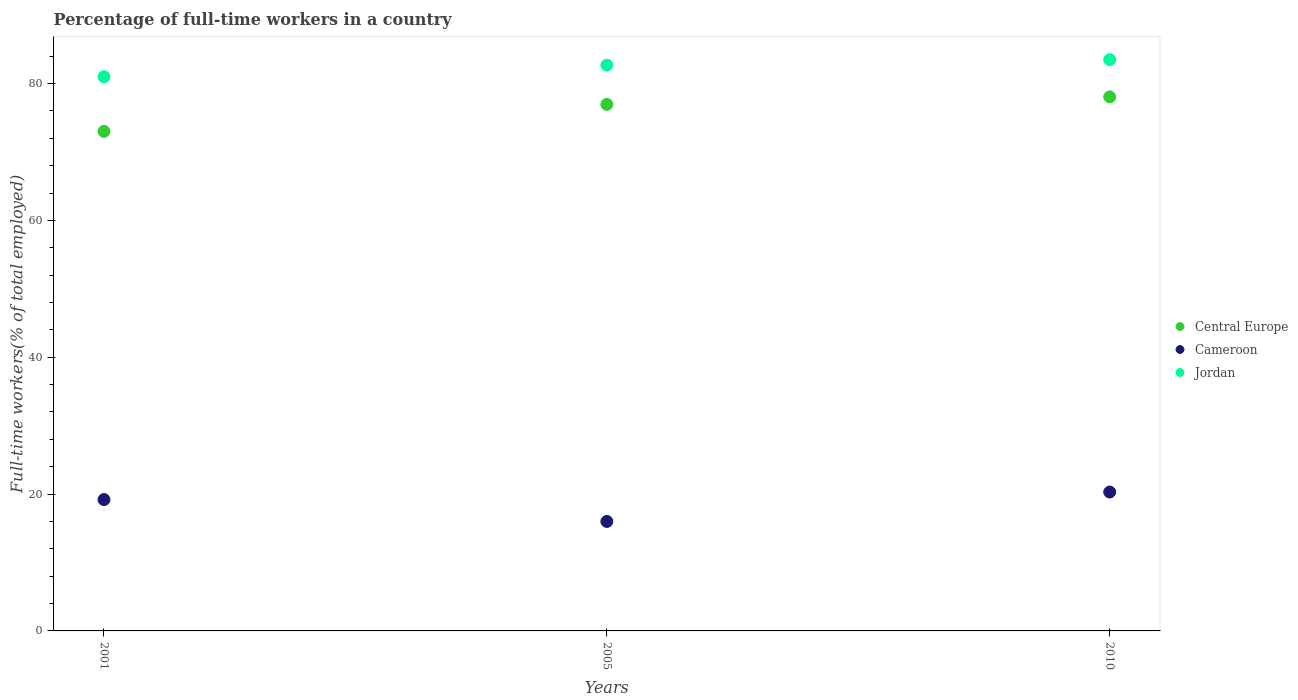Is the number of dotlines equal to the number of legend labels?
Offer a terse response. Yes. What is the percentage of full-time workers in Jordan in 2010?
Ensure brevity in your answer.  83.5. Across all years, what is the maximum percentage of full-time workers in Cameroon?
Give a very brief answer. 20.3. In which year was the percentage of full-time workers in Jordan maximum?
Your answer should be very brief. 2010. What is the total percentage of full-time workers in Jordan in the graph?
Offer a very short reply. 247.2. What is the difference between the percentage of full-time workers in Central Europe in 2001 and that in 2010?
Offer a very short reply. -5.04. What is the difference between the percentage of full-time workers in Central Europe in 2001 and the percentage of full-time workers in Cameroon in 2005?
Provide a short and direct response. 57.02. What is the average percentage of full-time workers in Cameroon per year?
Make the answer very short. 18.5. In the year 2010, what is the difference between the percentage of full-time workers in Central Europe and percentage of full-time workers in Cameroon?
Your answer should be very brief. 57.76. What is the ratio of the percentage of full-time workers in Central Europe in 2001 to that in 2005?
Ensure brevity in your answer.  0.95. Is the percentage of full-time workers in Jordan in 2005 less than that in 2010?
Your response must be concise. Yes. What is the difference between the highest and the second highest percentage of full-time workers in Central Europe?
Ensure brevity in your answer.  1.1. What is the difference between the highest and the lowest percentage of full-time workers in Central Europe?
Provide a short and direct response. 5.04. In how many years, is the percentage of full-time workers in Jordan greater than the average percentage of full-time workers in Jordan taken over all years?
Your response must be concise. 2. Is the percentage of full-time workers in Central Europe strictly greater than the percentage of full-time workers in Cameroon over the years?
Provide a succinct answer. Yes. Is the percentage of full-time workers in Jordan strictly less than the percentage of full-time workers in Central Europe over the years?
Keep it short and to the point. No. How many years are there in the graph?
Ensure brevity in your answer.  3. What is the difference between two consecutive major ticks on the Y-axis?
Ensure brevity in your answer.  20. Does the graph contain grids?
Offer a terse response. No. Where does the legend appear in the graph?
Your answer should be compact. Center right. How many legend labels are there?
Your answer should be compact. 3. How are the legend labels stacked?
Make the answer very short. Vertical. What is the title of the graph?
Make the answer very short. Percentage of full-time workers in a country. What is the label or title of the X-axis?
Provide a short and direct response. Years. What is the label or title of the Y-axis?
Give a very brief answer. Full-time workers(% of total employed). What is the Full-time workers(% of total employed) in Central Europe in 2001?
Give a very brief answer. 73.02. What is the Full-time workers(% of total employed) in Cameroon in 2001?
Your answer should be compact. 19.2. What is the Full-time workers(% of total employed) of Central Europe in 2005?
Give a very brief answer. 76.96. What is the Full-time workers(% of total employed) of Jordan in 2005?
Make the answer very short. 82.7. What is the Full-time workers(% of total employed) in Central Europe in 2010?
Your answer should be compact. 78.06. What is the Full-time workers(% of total employed) of Cameroon in 2010?
Give a very brief answer. 20.3. What is the Full-time workers(% of total employed) of Jordan in 2010?
Give a very brief answer. 83.5. Across all years, what is the maximum Full-time workers(% of total employed) of Central Europe?
Your answer should be compact. 78.06. Across all years, what is the maximum Full-time workers(% of total employed) of Cameroon?
Provide a succinct answer. 20.3. Across all years, what is the maximum Full-time workers(% of total employed) in Jordan?
Ensure brevity in your answer.  83.5. Across all years, what is the minimum Full-time workers(% of total employed) of Central Europe?
Your answer should be very brief. 73.02. What is the total Full-time workers(% of total employed) of Central Europe in the graph?
Offer a terse response. 228.04. What is the total Full-time workers(% of total employed) in Cameroon in the graph?
Provide a succinct answer. 55.5. What is the total Full-time workers(% of total employed) in Jordan in the graph?
Your response must be concise. 247.2. What is the difference between the Full-time workers(% of total employed) of Central Europe in 2001 and that in 2005?
Provide a succinct answer. -3.94. What is the difference between the Full-time workers(% of total employed) in Cameroon in 2001 and that in 2005?
Ensure brevity in your answer.  3.2. What is the difference between the Full-time workers(% of total employed) of Central Europe in 2001 and that in 2010?
Make the answer very short. -5.04. What is the difference between the Full-time workers(% of total employed) of Cameroon in 2001 and that in 2010?
Give a very brief answer. -1.1. What is the difference between the Full-time workers(% of total employed) in Central Europe in 2005 and that in 2010?
Provide a short and direct response. -1.1. What is the difference between the Full-time workers(% of total employed) of Jordan in 2005 and that in 2010?
Make the answer very short. -0.8. What is the difference between the Full-time workers(% of total employed) of Central Europe in 2001 and the Full-time workers(% of total employed) of Cameroon in 2005?
Your answer should be very brief. 57.02. What is the difference between the Full-time workers(% of total employed) of Central Europe in 2001 and the Full-time workers(% of total employed) of Jordan in 2005?
Provide a short and direct response. -9.68. What is the difference between the Full-time workers(% of total employed) in Cameroon in 2001 and the Full-time workers(% of total employed) in Jordan in 2005?
Give a very brief answer. -63.5. What is the difference between the Full-time workers(% of total employed) of Central Europe in 2001 and the Full-time workers(% of total employed) of Cameroon in 2010?
Offer a very short reply. 52.72. What is the difference between the Full-time workers(% of total employed) in Central Europe in 2001 and the Full-time workers(% of total employed) in Jordan in 2010?
Make the answer very short. -10.48. What is the difference between the Full-time workers(% of total employed) of Cameroon in 2001 and the Full-time workers(% of total employed) of Jordan in 2010?
Offer a terse response. -64.3. What is the difference between the Full-time workers(% of total employed) in Central Europe in 2005 and the Full-time workers(% of total employed) in Cameroon in 2010?
Your response must be concise. 56.66. What is the difference between the Full-time workers(% of total employed) of Central Europe in 2005 and the Full-time workers(% of total employed) of Jordan in 2010?
Keep it short and to the point. -6.54. What is the difference between the Full-time workers(% of total employed) of Cameroon in 2005 and the Full-time workers(% of total employed) of Jordan in 2010?
Provide a short and direct response. -67.5. What is the average Full-time workers(% of total employed) in Central Europe per year?
Offer a very short reply. 76.01. What is the average Full-time workers(% of total employed) in Cameroon per year?
Offer a very short reply. 18.5. What is the average Full-time workers(% of total employed) of Jordan per year?
Offer a terse response. 82.4. In the year 2001, what is the difference between the Full-time workers(% of total employed) in Central Europe and Full-time workers(% of total employed) in Cameroon?
Make the answer very short. 53.82. In the year 2001, what is the difference between the Full-time workers(% of total employed) in Central Europe and Full-time workers(% of total employed) in Jordan?
Offer a very short reply. -7.98. In the year 2001, what is the difference between the Full-time workers(% of total employed) of Cameroon and Full-time workers(% of total employed) of Jordan?
Keep it short and to the point. -61.8. In the year 2005, what is the difference between the Full-time workers(% of total employed) of Central Europe and Full-time workers(% of total employed) of Cameroon?
Offer a very short reply. 60.96. In the year 2005, what is the difference between the Full-time workers(% of total employed) in Central Europe and Full-time workers(% of total employed) in Jordan?
Your answer should be compact. -5.74. In the year 2005, what is the difference between the Full-time workers(% of total employed) in Cameroon and Full-time workers(% of total employed) in Jordan?
Offer a terse response. -66.7. In the year 2010, what is the difference between the Full-time workers(% of total employed) of Central Europe and Full-time workers(% of total employed) of Cameroon?
Make the answer very short. 57.76. In the year 2010, what is the difference between the Full-time workers(% of total employed) of Central Europe and Full-time workers(% of total employed) of Jordan?
Keep it short and to the point. -5.44. In the year 2010, what is the difference between the Full-time workers(% of total employed) of Cameroon and Full-time workers(% of total employed) of Jordan?
Give a very brief answer. -63.2. What is the ratio of the Full-time workers(% of total employed) of Central Europe in 2001 to that in 2005?
Keep it short and to the point. 0.95. What is the ratio of the Full-time workers(% of total employed) in Jordan in 2001 to that in 2005?
Your answer should be very brief. 0.98. What is the ratio of the Full-time workers(% of total employed) in Central Europe in 2001 to that in 2010?
Keep it short and to the point. 0.94. What is the ratio of the Full-time workers(% of total employed) in Cameroon in 2001 to that in 2010?
Your response must be concise. 0.95. What is the ratio of the Full-time workers(% of total employed) of Jordan in 2001 to that in 2010?
Give a very brief answer. 0.97. What is the ratio of the Full-time workers(% of total employed) in Central Europe in 2005 to that in 2010?
Provide a short and direct response. 0.99. What is the ratio of the Full-time workers(% of total employed) in Cameroon in 2005 to that in 2010?
Ensure brevity in your answer.  0.79. What is the difference between the highest and the second highest Full-time workers(% of total employed) of Central Europe?
Keep it short and to the point. 1.1. What is the difference between the highest and the second highest Full-time workers(% of total employed) in Jordan?
Make the answer very short. 0.8. What is the difference between the highest and the lowest Full-time workers(% of total employed) in Central Europe?
Offer a terse response. 5.04. What is the difference between the highest and the lowest Full-time workers(% of total employed) in Cameroon?
Offer a terse response. 4.3. What is the difference between the highest and the lowest Full-time workers(% of total employed) of Jordan?
Your answer should be very brief. 2.5. 